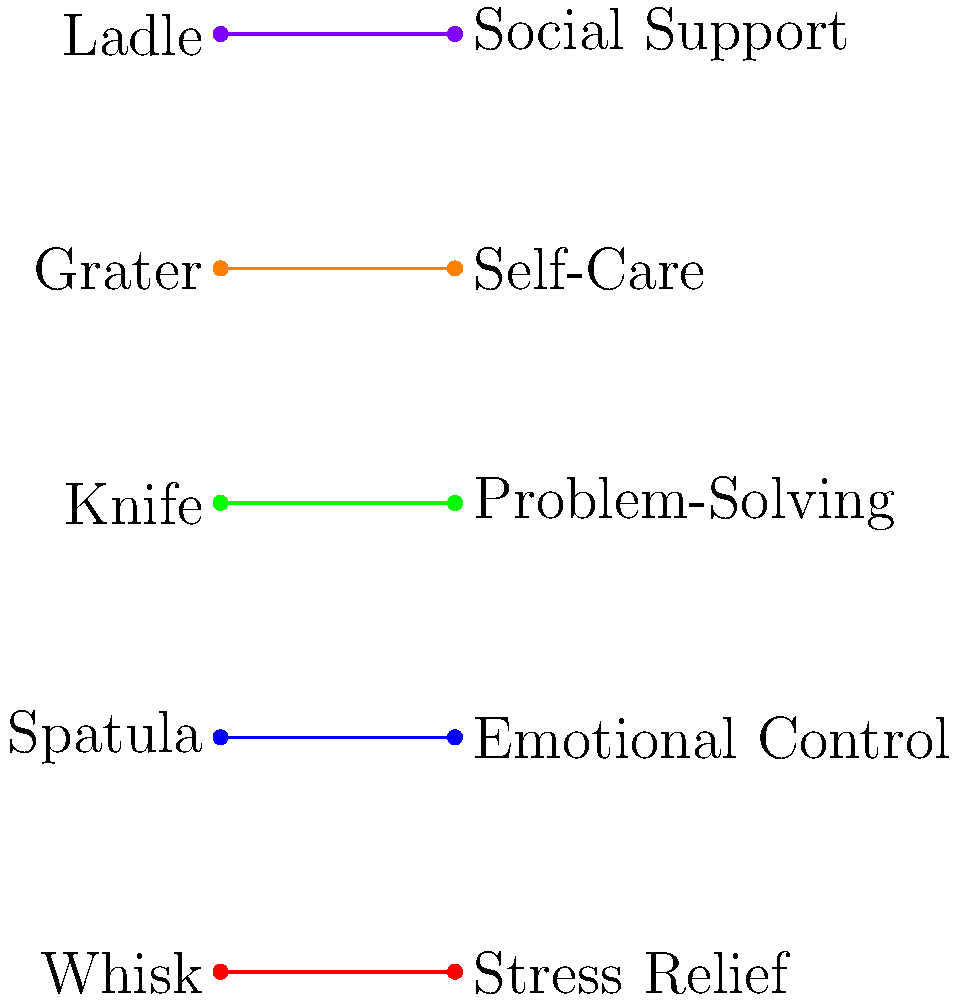In the context of mental health and cooking, match the cooking utensils with the most appropriate coping mechanisms. Which utensil-mechanism pair represents the act of reaching out to others for emotional support? To answer this question, we need to analyze each utensil-mechanism pair and their potential metaphorical connections:

1. Whisk - Stress Relief: The repetitive motion of whisking can be calming and relieve stress.
2. Spatula - Emotional Control: A spatula's ability to smooth and level foods can represent emotional regulation.
3. Knife - Problem-Solving: A knife's precision in cutting through ingredients can symbolize dissecting and solving problems.
4. Grater - Self-Care: The act of grating, which often adds flavor or texture to dishes, can represent adding positive elements to one's life.
5. Ladle - Social Support: A ladle is used for serving and sharing food, which can symbolize reaching out and providing support to others.

The question asks specifically about reaching out to others for emotional support. Among the given pairs, the Ladle - Social Support combination best represents this concept. A ladle is used to serve and share food with others, which metaphorically aligns with the idea of reaching out and offering or receiving emotional support in a social context.
Answer: Ladle - Social Support 